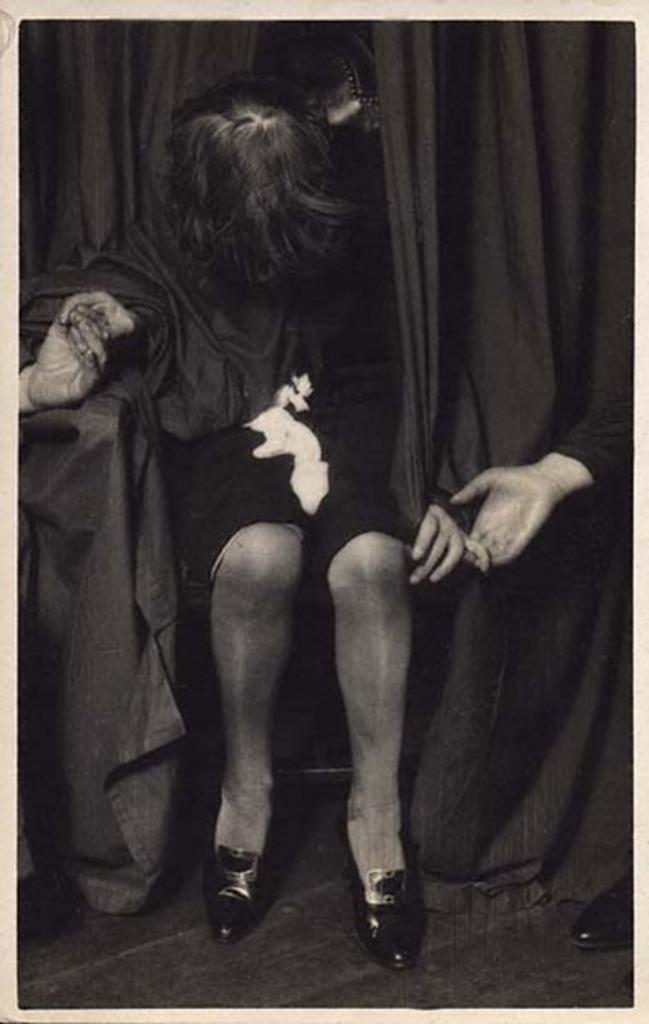Who or what is present in the image? There is a person in the image. What is the person wearing? The person is wearing a black dress. What else can be seen in the image besides the person? There are curtains in the image. What type of hose is being used by the person in the image? There is no hose present in the image. Can you describe the flower arrangement on the table in the image? There is no flower arrangement or table present in the image. 